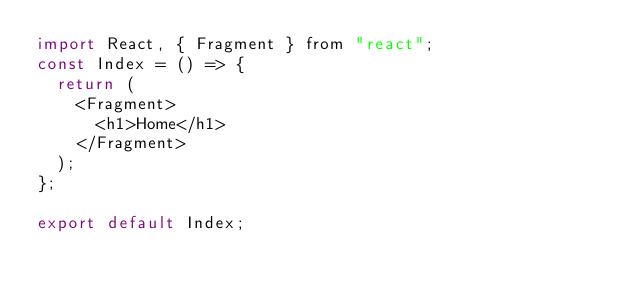<code> <loc_0><loc_0><loc_500><loc_500><_JavaScript_>import React, { Fragment } from "react";
const Index = () => {
  return (
    <Fragment>
      <h1>Home</h1>
    </Fragment>
  );
};

export default Index;
</code> 